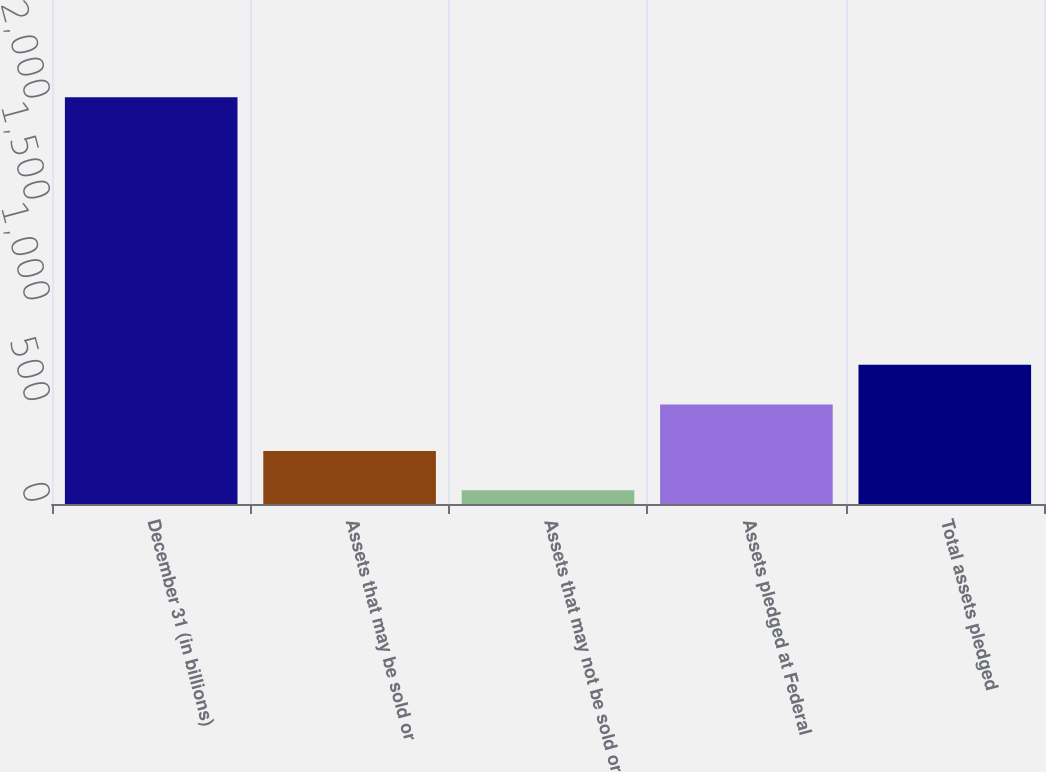Convert chart to OTSL. <chart><loc_0><loc_0><loc_500><loc_500><bar_chart><fcel>December 31 (in billions)<fcel>Assets that may be sold or<fcel>Assets that may not be sold or<fcel>Assets pledged at Federal<fcel>Total assets pledged<nl><fcel>2017<fcel>262.81<fcel>67.9<fcel>493.7<fcel>691.2<nl></chart> 